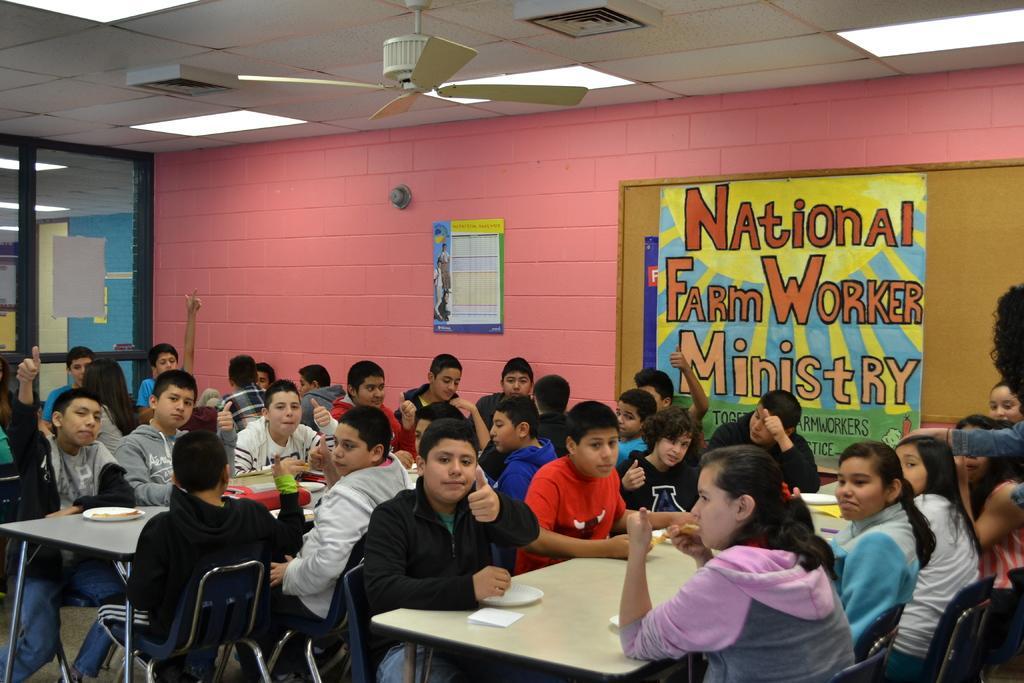In one or two sentences, can you explain what this image depicts? Here we can see some persons are sitting on the chairs. These are the tables. On the table there are plates. On the background there is a wall and this is board. Here we can see a poster. There is a door and this is fan. There are lights and this is roof. 